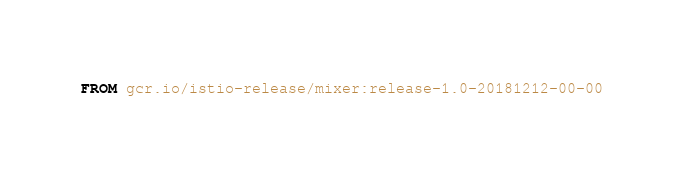Convert code to text. <code><loc_0><loc_0><loc_500><loc_500><_Dockerfile_>FROM gcr.io/istio-release/mixer:release-1.0-20181212-00-00
</code> 